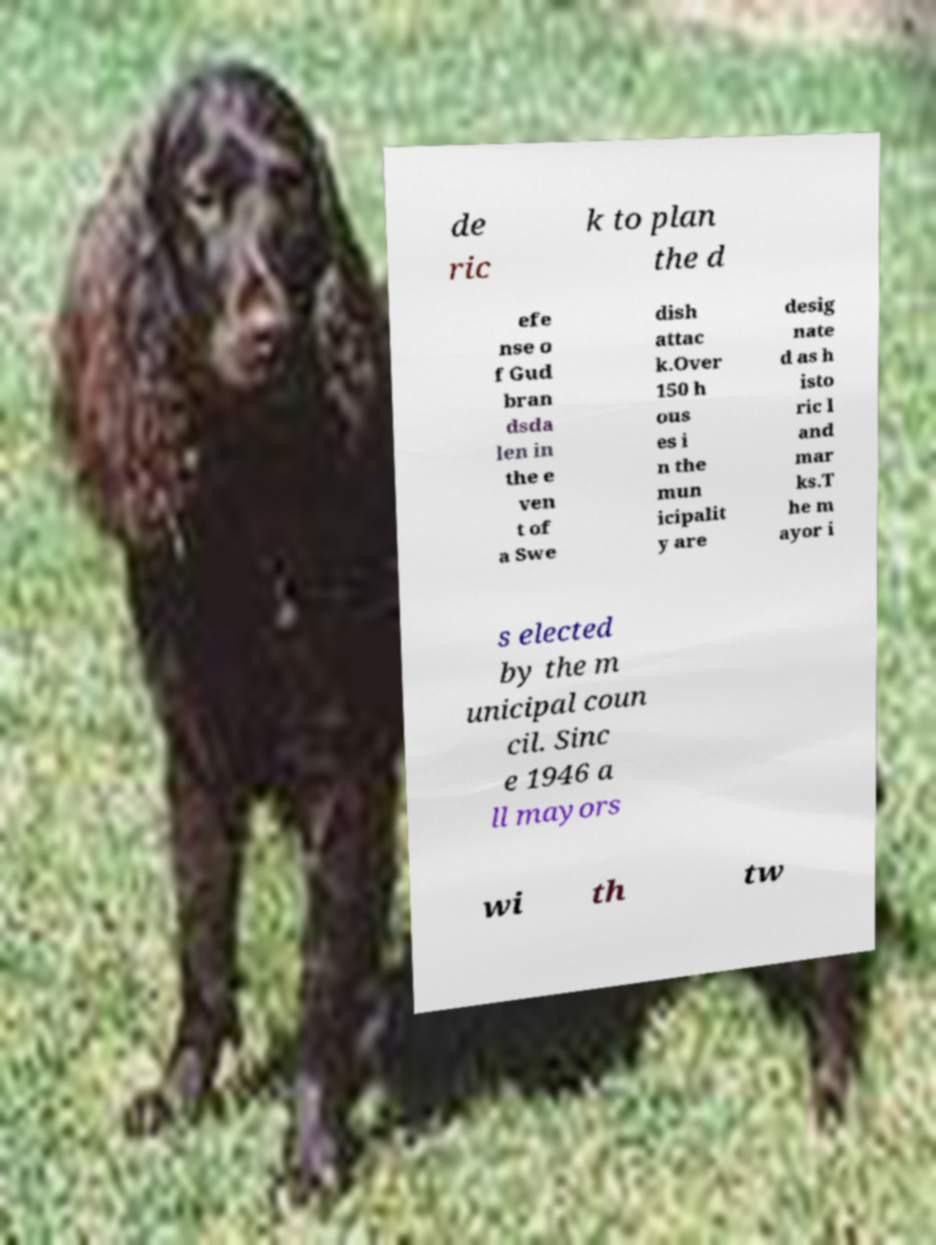I need the written content from this picture converted into text. Can you do that? de ric k to plan the d efe nse o f Gud bran dsda len in the e ven t of a Swe dish attac k.Over 150 h ous es i n the mun icipalit y are desig nate d as h isto ric l and mar ks.T he m ayor i s elected by the m unicipal coun cil. Sinc e 1946 a ll mayors wi th tw 